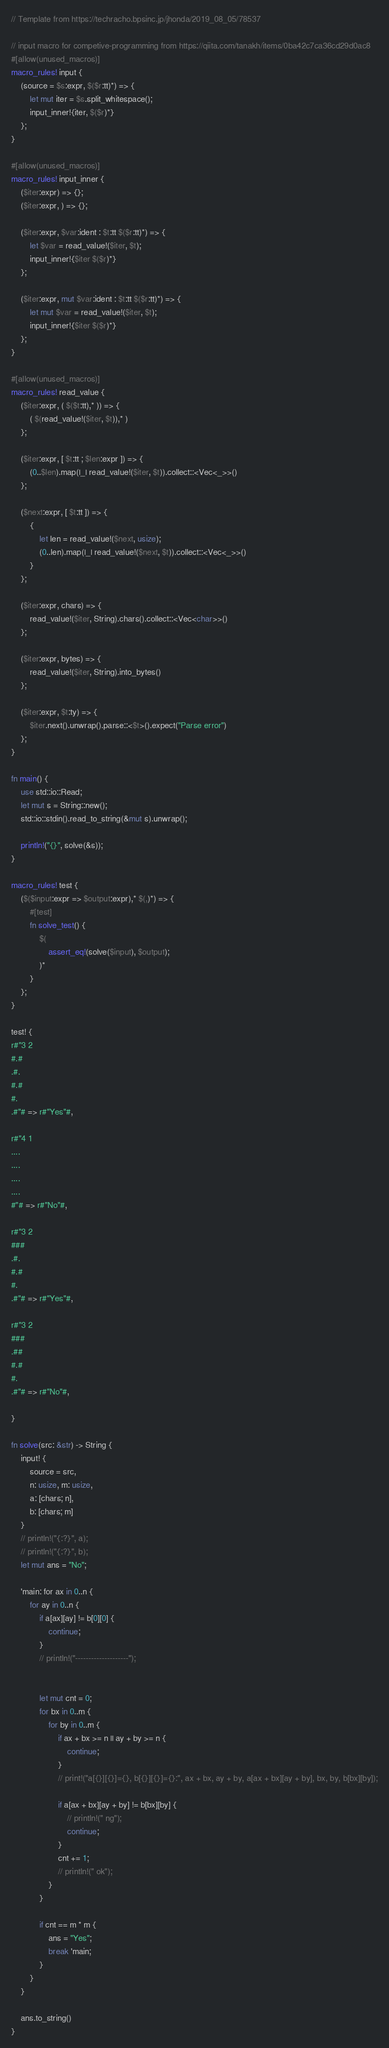Convert code to text. <code><loc_0><loc_0><loc_500><loc_500><_Rust_>// Template from https://techracho.bpsinc.jp/jhonda/2019_08_05/78537

// input macro for competive-programming from https://qiita.com/tanakh/items/0ba42c7ca36cd29d0ac8
#[allow(unused_macros)]
macro_rules! input {
    (source = $s:expr, $($r:tt)*) => {
        let mut iter = $s.split_whitespace();
        input_inner!{iter, $($r)*}
    };
}

#[allow(unused_macros)]
macro_rules! input_inner {
    ($iter:expr) => {};
    ($iter:expr, ) => {};

    ($iter:expr, $var:ident : $t:tt $($r:tt)*) => {
        let $var = read_value!($iter, $t);
        input_inner!{$iter $($r)*}
    };

    ($iter:expr, mut $var:ident : $t:tt $($r:tt)*) => {
        let mut $var = read_value!($iter, $t);
        input_inner!{$iter $($r)*}
    };
}

#[allow(unused_macros)]
macro_rules! read_value {
    ($iter:expr, ( $($t:tt),* )) => {
        ( $(read_value!($iter, $t)),* )
    };

    ($iter:expr, [ $t:tt ; $len:expr ]) => {
        (0..$len).map(|_| read_value!($iter, $t)).collect::<Vec<_>>()
    };

    ($next:expr, [ $t:tt ]) => {
        {
            let len = read_value!($next, usize);
            (0..len).map(|_| read_value!($next, $t)).collect::<Vec<_>>()
        }
    };

    ($iter:expr, chars) => {
        read_value!($iter, String).chars().collect::<Vec<char>>()
    };

    ($iter:expr, bytes) => {
        read_value!($iter, String).into_bytes()
    };

    ($iter:expr, $t:ty) => {
        $iter.next().unwrap().parse::<$t>().expect("Parse error")
    };
}

fn main() {
    use std::io::Read;
    let mut s = String::new();
    std::io::stdin().read_to_string(&mut s).unwrap();

    println!("{}", solve(&s));
}

macro_rules! test {
    ($($input:expr => $output:expr),* $(,)*) => {
        #[test]
        fn solve_test() {
            $(
                assert_eq!(solve($input), $output);
            )*
        }
    };
}

test! {
r#"3 2
#.#
.#.
#.#
#.
.#"# => r#"Yes"#,

r#"4 1
....
....
....
....
#"# => r#"No"#,

r#"3 2
###
.#.
#.#
#.
.#"# => r#"Yes"#,

r#"3 2
###
.##
#.#
#.
.#"# => r#"No"#,

}

fn solve(src: &str) -> String {
    input! {
        source = src,
        n: usize, m: usize,
        a: [chars; n],
        b: [chars; m]
    }
    // println!("{:?}", a);
    // println!("{:?}", b);
    let mut ans = "No";

    'main: for ax in 0..n {
        for ay in 0..n {
            if a[ax][ay] != b[0][0] {
                continue;
            }
            // println!("--------------------");


            let mut cnt = 0;
            for bx in 0..m {
                for by in 0..m {
                    if ax + bx >= n || ay + by >= n {
                        continue;
                    }
                    // print!("a[{}][{}]={}, b[{}][{}]={}:", ax + bx, ay + by, a[ax + bx][ay + by], bx, by, b[bx][by]);

                    if a[ax + bx][ay + by] != b[bx][by] {
                        // println!(" ng");
                        continue;
                    }
                    cnt += 1;
                    // println!(" ok");
                }
            }

            if cnt == m * m {
                ans = "Yes";
                break 'main;
            }
        }
    }

    ans.to_string()
}</code> 